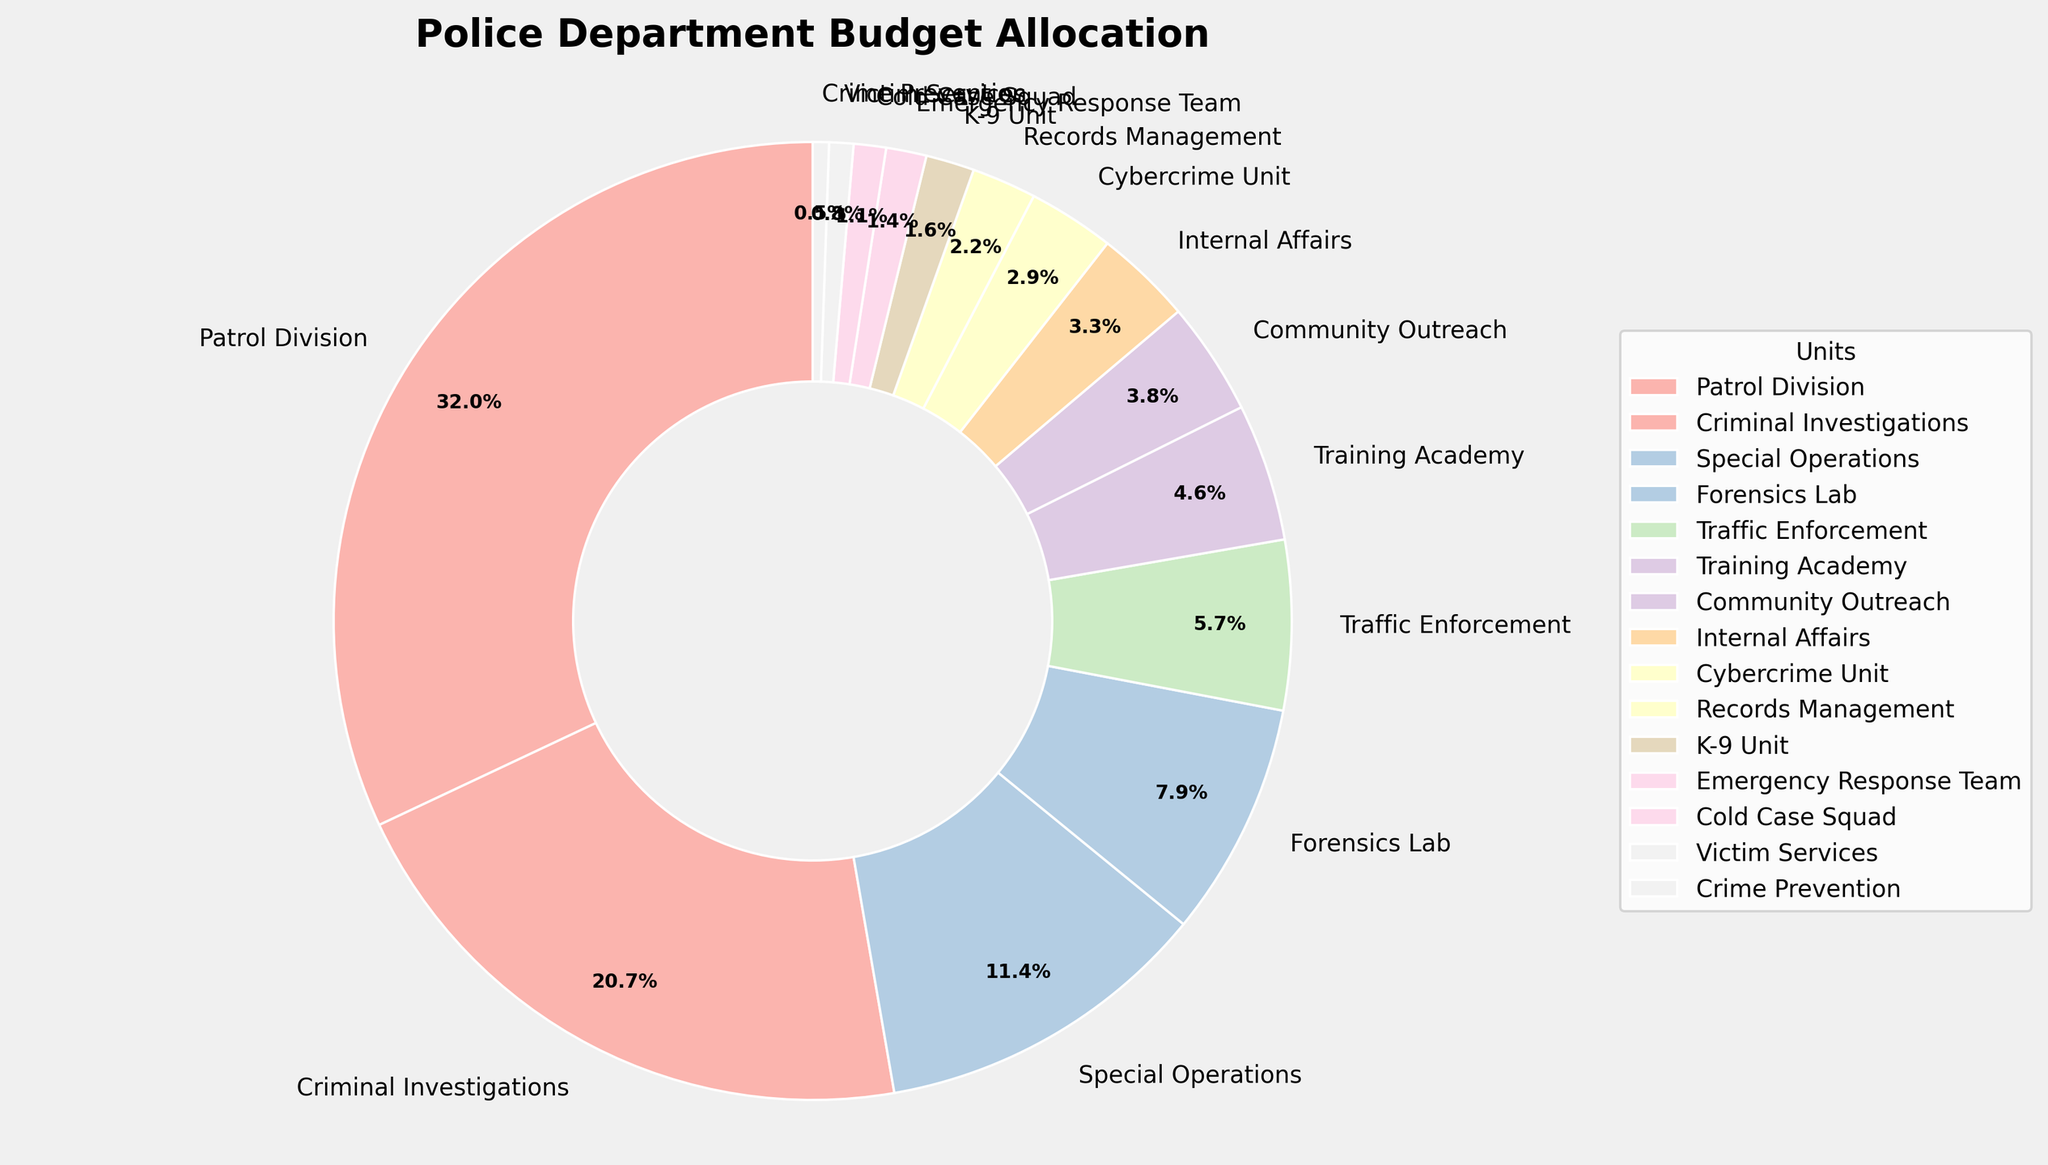Which unit has the highest budget allocation? The Patrol Division has the largest slice of the pie chart, indicating the highest budget allocation at 35.2%.
Answer: Patrol Division What is the combined budget allocation for Criminal Investigations and Special Operations? The Criminal Investigations allocation is 22.8%, and Special Operations is 12.5%. Adding them together: 22.8% + 12.5% = 35.3%.
Answer: 35.3% Which unit has the smallest budget allocation? The Crime Prevention unit has the smallest slice of the pie chart, indicating the lowest budget allocation at 0.6%.
Answer: Crime Prevention Is the budget allocation of Traffic Enforcement greater than Training Academy? Traffic Enforcement has an allocation of 6.3%, and Training Academy is allocated 5.1%. Since 6.3% > 5.1%, Traffic Enforcement has a greater allocation.
Answer: Yes What is the total budget allocation for units with less than 5% allocation each? The units with less than 5% allocation are Training Academy (5.1%), Community Outreach (4.2%), Internal Affairs (3.6%), Cybercrime Unit (3.2%), Records Management (2.4%), K-9 Unit (1.8%), Emergency Response Team (1.5%), Cold Case Squad (1.2%), Victim Services (0.9%), Crime Prevention (0.6%). Adding these up: 5.1% + 4.2% + 3.6% + 3.2% + 2.4% + 1.8% + 1.5% + 1.2% + 0.9% + 0.6% = 24.5%.
Answer: 24.5% How many units have a budget allocation greater than 10% but less than 30%? Dividing the pie chart visually, we see that Criminal Investigations (22.8%) and Special Operations (12.5%) fall within the specified range. So, the number of units is 2.
Answer: 2 What is the difference in budget allocation between the Emergency Response Team and the Cold Case Squad? The Emergency Response Team is allocated 1.5%, and the Cold Case Squad is allocated 1.2%. The difference is calculated as 1.5% - 1.2% = 0.3%.
Answer: 0.3% Does the Forensics Lab have a higher budget allocation than Community Outreach? The Forensics Lab has 8.7%, while Community Outreach has 4.2%. Since 8.7% > 4.2%, Forensics Lab has a higher budget allocation.
Answer: Yes Which three units have the highest budget allocations? The three largest slices in the pie chart belong to Patrol Division (35.2%), Criminal Investigations (22.8%), and Special Operations (12.5%).
Answer: Patrol Division, Criminal Investigations, Special Operations Compare the budget allocation of Cybercrime Unit and Records Management. Cybercrime Unit has a budget allocation of 3.2%, while Records Management has 2.4%. 3.2% is greater than 2.4%, so Cybercrime Unit has a larger allocation.
Answer: Cybercrime Unit 